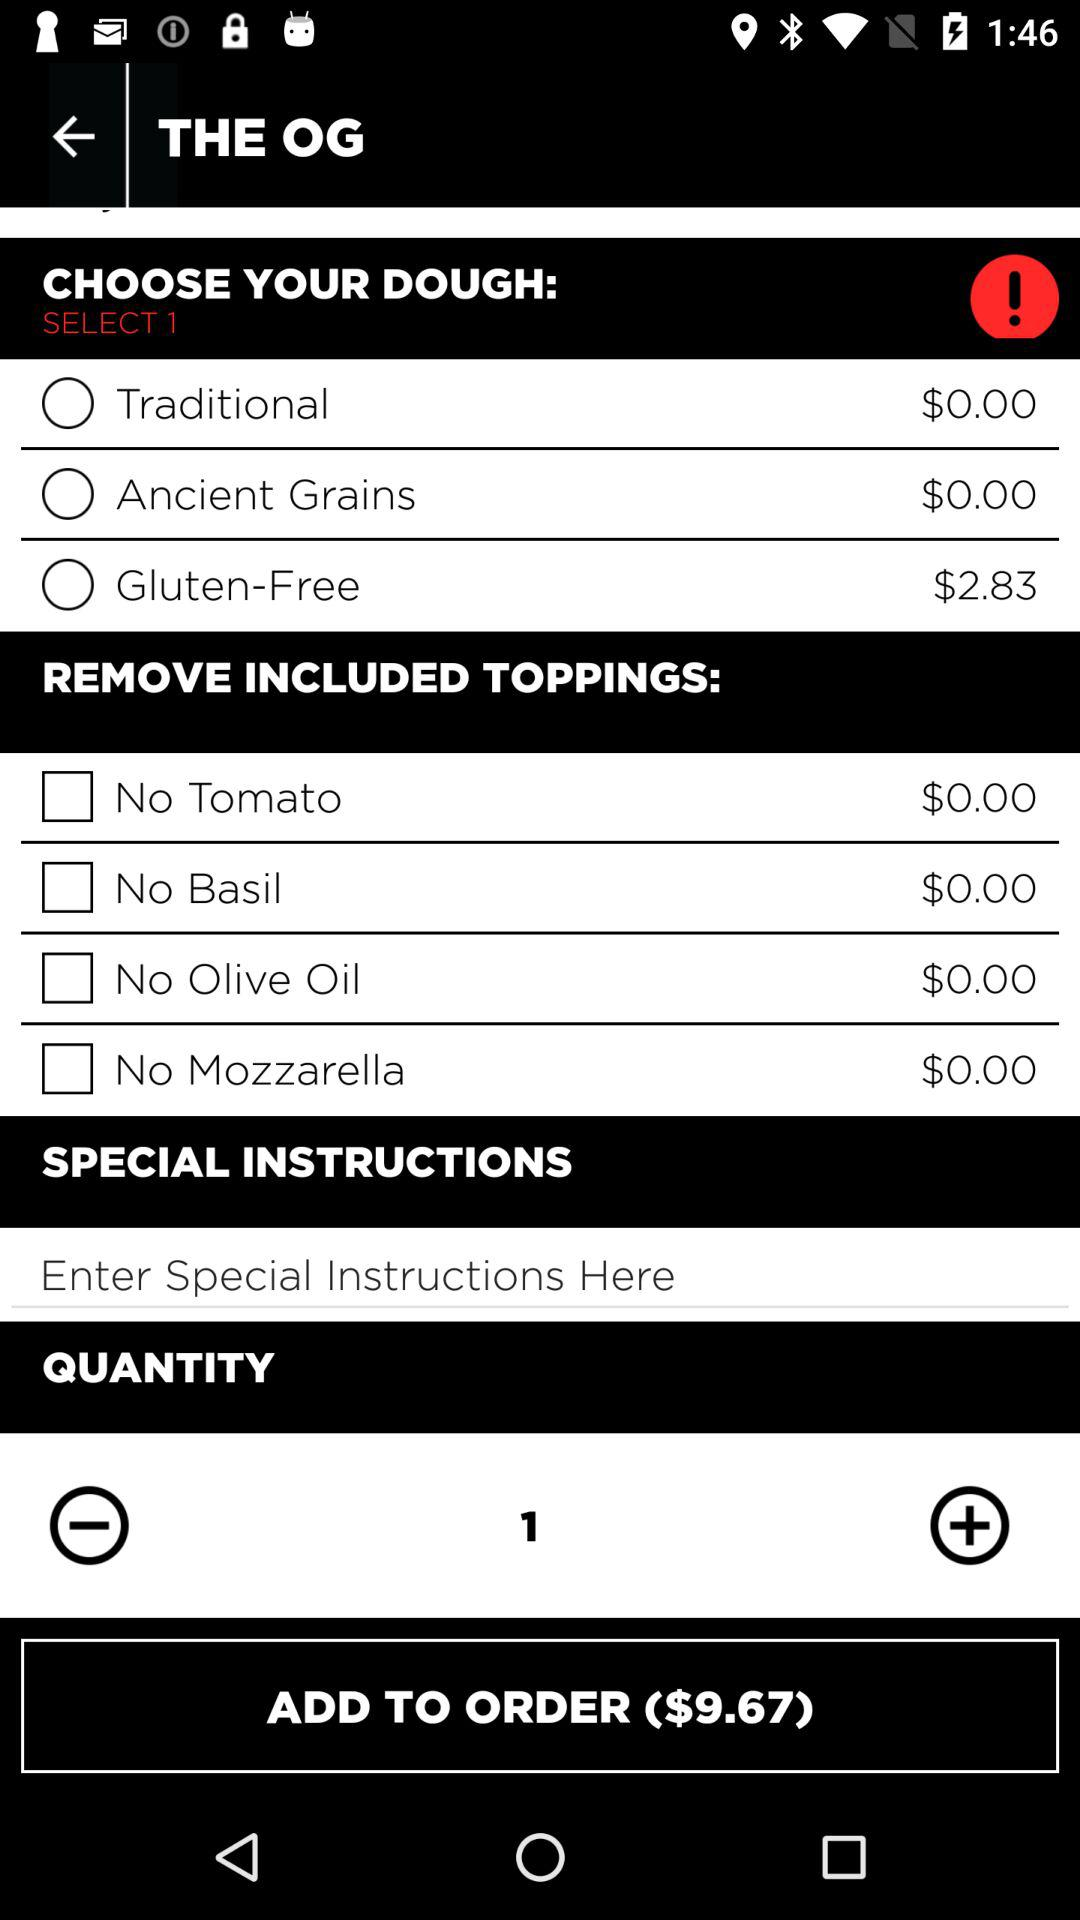What is the selected quantity? The selected quantity is 1. 